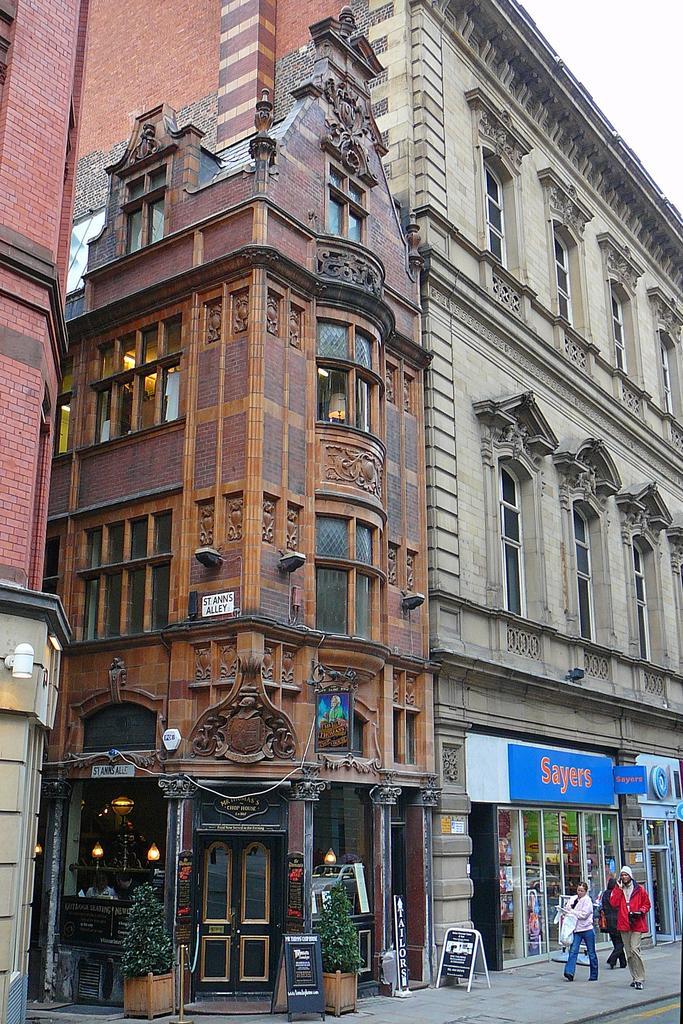In one or two sentences, can you explain what this image depicts? This picture is clicked outside the city. In the right bottom of the picture, we see three people walking on the sideways. Beside them, we see buildings and these buildings are in red and brown color. At the bottom of the picture, we see black color boards with text written on it. Beside that, we see flower pots. At the top of the picture, we see the sky. We see a blue color hoarding board with text written as "SAYERS". 